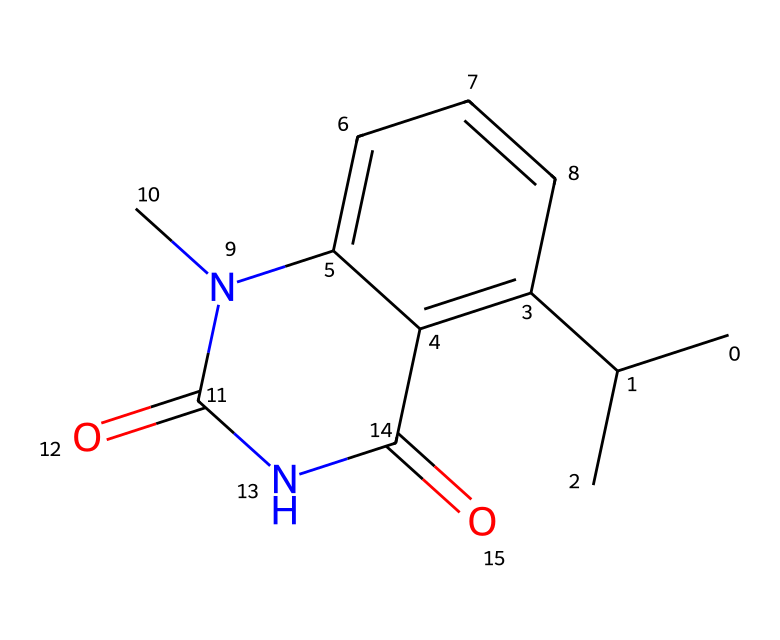What is the molecular formula of this drug? By analyzing the SMILES representation, we can identify each atom present in the structure. Counting the atoms gives us: Carbon (C) = 12, Hydrogen (H) = 15, Nitrogen (N) = 2, and Oxygen (O) = 2. Therefore, the molecular formula is C12H15N2O2.
Answer: C12H15N2O2 How many rings does this chemical structure contain? The SMILES indicates that there are two cycles present. These are identified in the structure with the notation “C1” and “C2”, which signify ring closures. Thus, the total count of rings is 2.
Answer: 2 What functional groups are present in this drug? From the structure derived from the SMILES, we can identify functional groups such as amide (due to the -C(=O)N- structure) and ketone (indicated by -C(=O)-). Both of these groups help characterize the drug as a compound used in medical applications.
Answer: amide, ketone Is there a chiral center in this chemical? To determine chirality, we look for tetrahedral carbon atoms attached to four different substituents. The structure has a carbon atom (C) bonded to different groups, indicating the presence of a chiral center.
Answer: yes What does the presence of nitrogen atoms suggest about this drug? Nitrogen atoms in a chemical structure typically indicate the presence of basic properties and are often found in many drugs. In this drug, nitrogen contributes to its efficacy, as it may influence interactions with biological targets, specifically in antimalarial activity.
Answer: basic properties What is the significance of the carbon chain in medicinal chemistry? The carbon chain contributes to the molecule's hydrophobic properties, influencing its absorption and distribution in the body. This structural feature is significant as it affects how well the drug can traverse biological membranes, which is crucial in drug design.
Answer: hydrophobic properties 